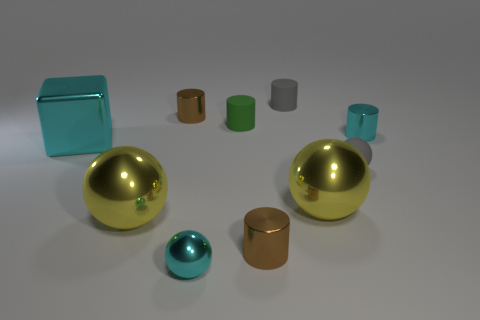Subtract all tiny cyan shiny balls. How many balls are left? 3 Subtract 1 cylinders. How many cylinders are left? 4 Subtract all brown blocks. How many yellow balls are left? 2 Subtract all gray cylinders. How many cylinders are left? 4 Add 1 yellow spheres. How many yellow spheres are left? 3 Add 4 big cyan cubes. How many big cyan cubes exist? 5 Subtract 0 purple cylinders. How many objects are left? 10 Subtract all blocks. How many objects are left? 9 Subtract all gray cubes. Subtract all purple cylinders. How many cubes are left? 1 Subtract all brown metal cylinders. Subtract all brown things. How many objects are left? 6 